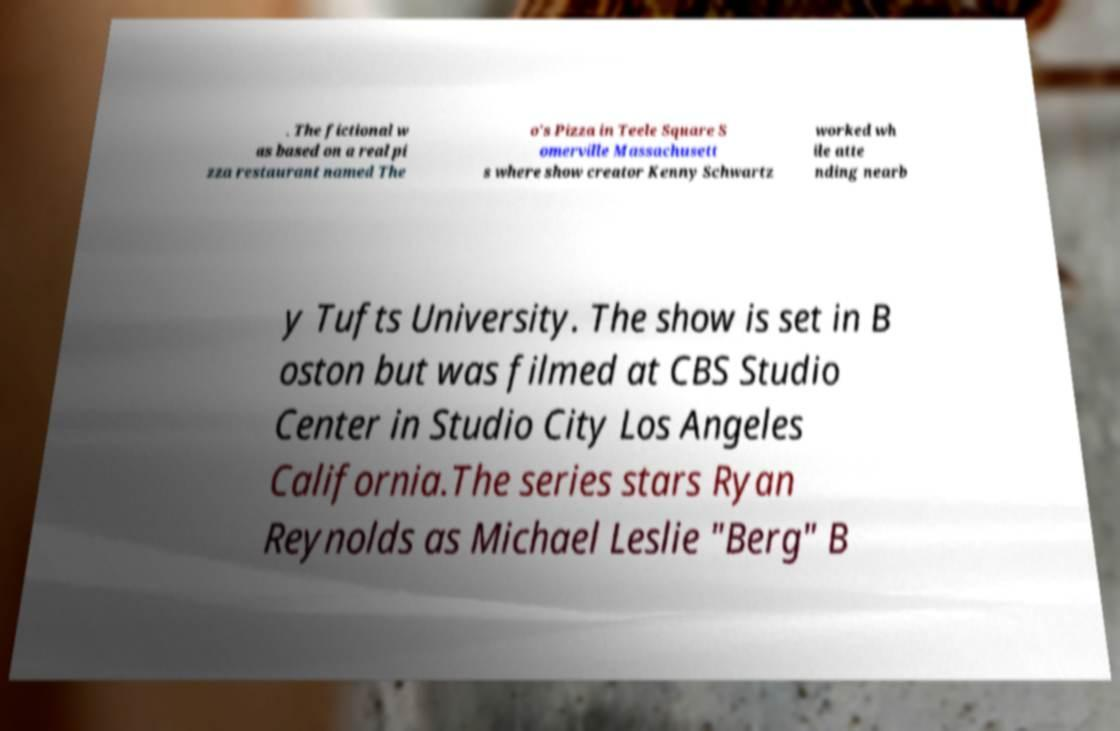Please identify and transcribe the text found in this image. . The fictional w as based on a real pi zza restaurant named The o's Pizza in Teele Square S omerville Massachusett s where show creator Kenny Schwartz worked wh ile atte nding nearb y Tufts University. The show is set in B oston but was filmed at CBS Studio Center in Studio City Los Angeles California.The series stars Ryan Reynolds as Michael Leslie "Berg" B 